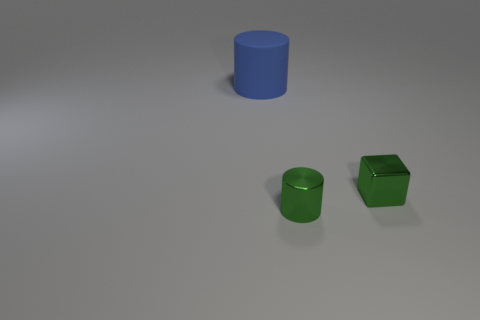The small thing that is the same color as the tiny shiny cylinder is what shape?
Offer a very short reply. Cube. There is a green shiny thing that is behind the small thing on the left side of the tiny green metal block; how big is it?
Ensure brevity in your answer.  Small. Do the small green thing that is in front of the metal cube and the big blue thing behind the tiny block have the same shape?
Provide a short and direct response. Yes. Are there an equal number of small green cubes that are behind the big blue object and brown balls?
Offer a very short reply. Yes. What is the color of the small object that is the same shape as the large rubber object?
Your answer should be compact. Green. Is the tiny green thing that is behind the metallic cylinder made of the same material as the blue cylinder?
Provide a succinct answer. No. How many tiny objects are green metal blocks or red spheres?
Keep it short and to the point. 1. The green cylinder is what size?
Ensure brevity in your answer.  Small. Do the metallic cube and the cylinder in front of the large rubber cylinder have the same size?
Offer a very short reply. Yes. What number of gray objects are big things or cylinders?
Ensure brevity in your answer.  0. 